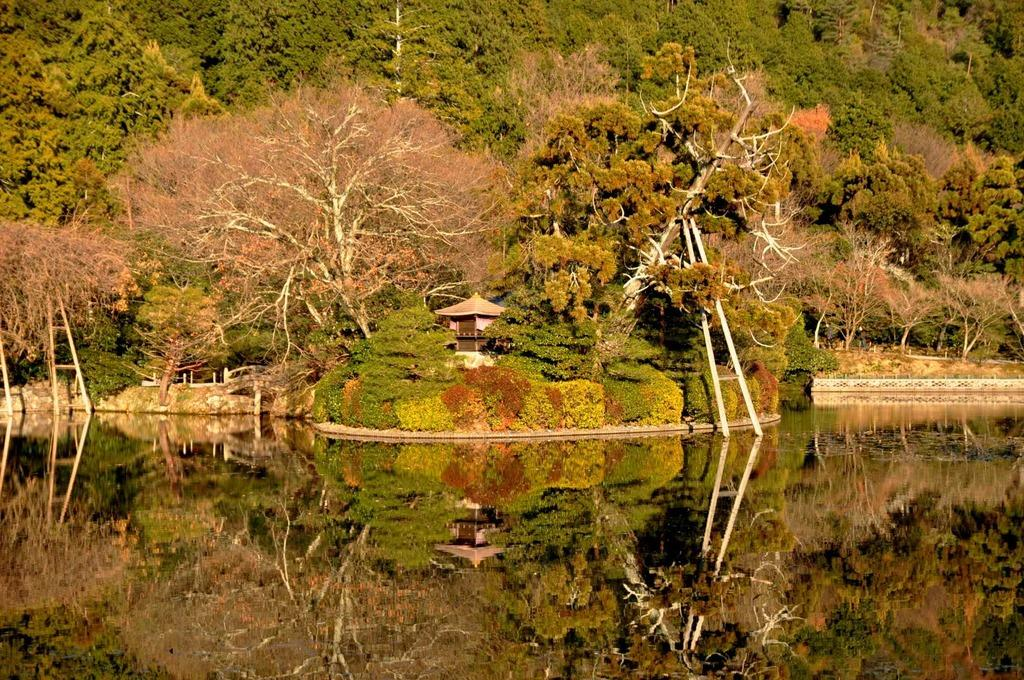What type of vegetation can be seen in the image? There are trees in the image. What colors are the trees in the image? The trees have green and brown colors. What type of structure is present in the image? There is a house in the image. What natural element is visible in the image? There is water visible in the image. What hobbies do the trees enjoy during recess in the image? There are no hobbies or recess depicted in the image, as it features trees, a house, and water. How does the image change when viewed from a different angle? The image does not change when viewed from a different angle, as it is a static representation of the scene. 